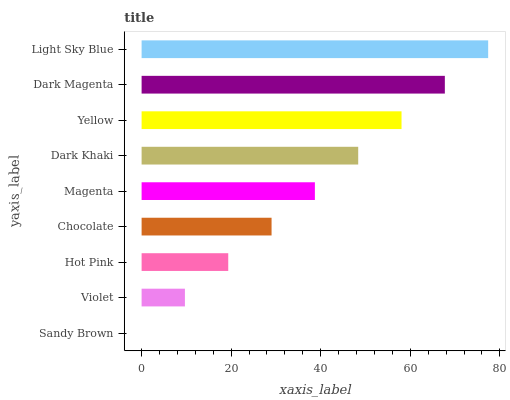Is Sandy Brown the minimum?
Answer yes or no. Yes. Is Light Sky Blue the maximum?
Answer yes or no. Yes. Is Violet the minimum?
Answer yes or no. No. Is Violet the maximum?
Answer yes or no. No. Is Violet greater than Sandy Brown?
Answer yes or no. Yes. Is Sandy Brown less than Violet?
Answer yes or no. Yes. Is Sandy Brown greater than Violet?
Answer yes or no. No. Is Violet less than Sandy Brown?
Answer yes or no. No. Is Magenta the high median?
Answer yes or no. Yes. Is Magenta the low median?
Answer yes or no. Yes. Is Hot Pink the high median?
Answer yes or no. No. Is Light Sky Blue the low median?
Answer yes or no. No. 